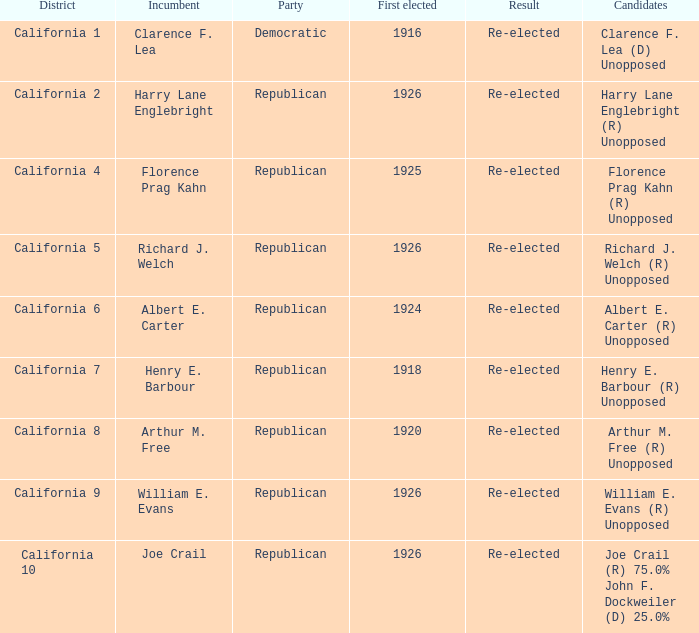 how many candidates with district being california 7 1.0. 